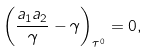Convert formula to latex. <formula><loc_0><loc_0><loc_500><loc_500>\left ( \frac { a _ { 1 } a _ { 2 } } { \gamma } - \gamma \right ) _ { \tau ^ { 0 } } = 0 ,</formula> 